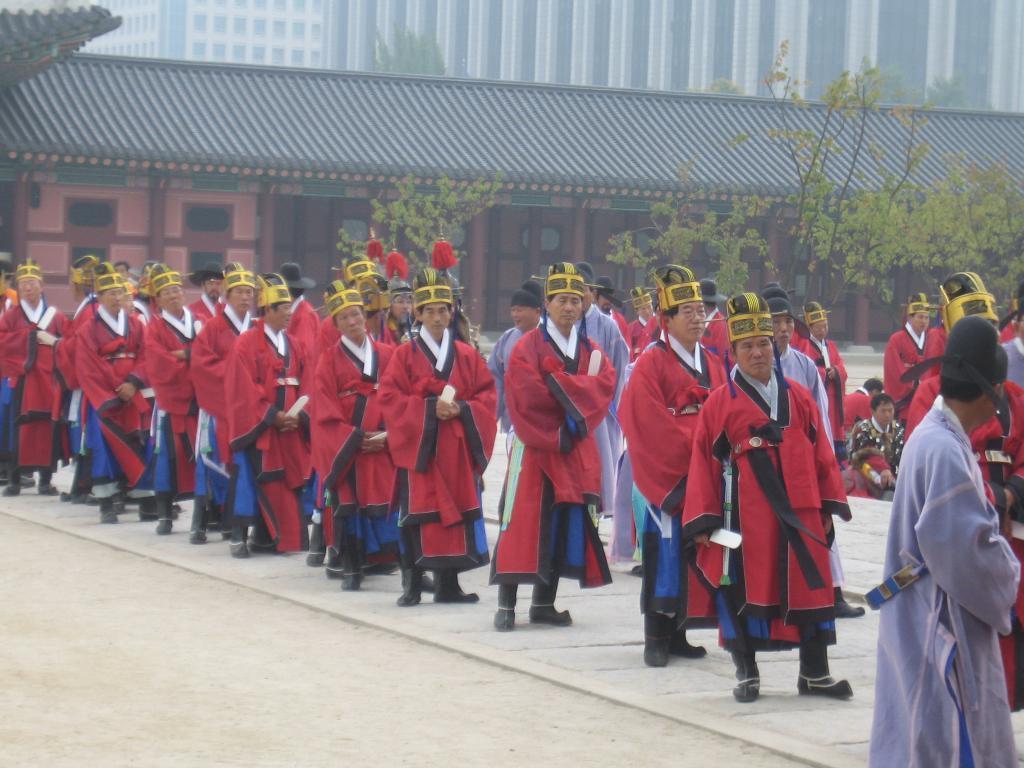Can you describe this image briefly? In this picture there are group of people standing and there are two people sitting. At the back there are buildings and trees. At the bottom there is a road. 